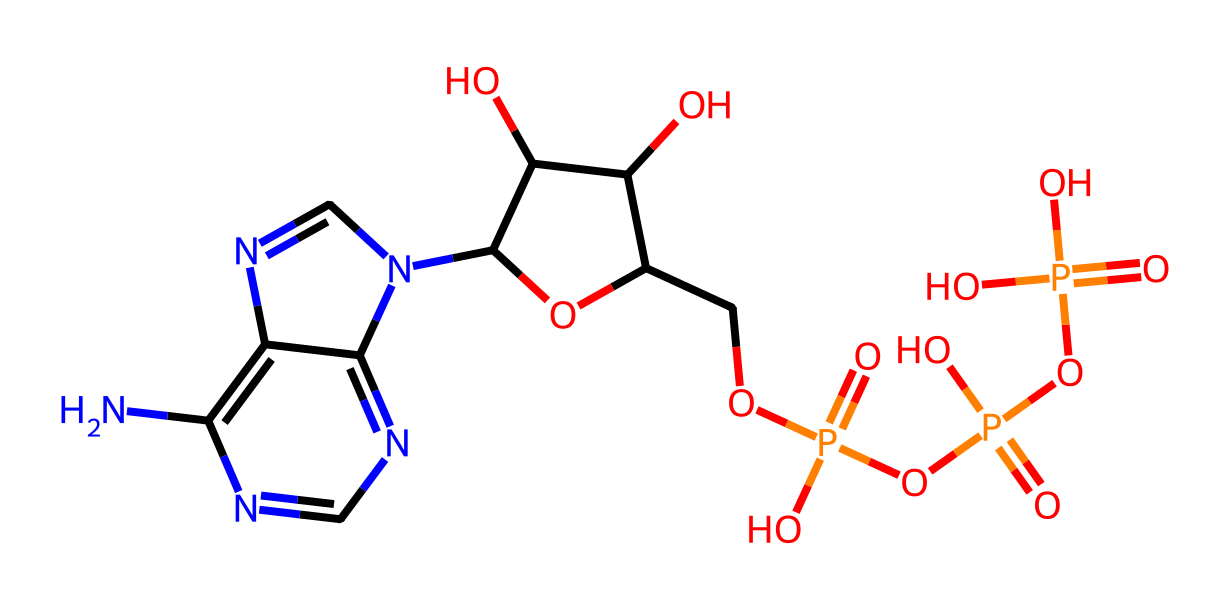What is the main role of ATP in muscles during intense activity? ATP provides energy for muscle contractions, as it is the primary energy carrier in living cells.
Answer: energy carrier How many phosphate groups are present in ATP? ATP contains three phosphate groups attached to its structure, which are crucial for its energetic functions.
Answer: three Which part of the structure indicates that it is a nucleotide? The presence of the ribose sugar and the nitrogenous base (adenine) indicate that ATP is a nucleotide.
Answer: ribose sugar and adenine What type of bond links the phosphate groups in ATP? The phosphate groups in ATP are linked by high-energy phosphoanhydride bonds, essential for energy transfer.
Answer: phosphoanhydride bonds What is the empirical formula of ATP? The empirical formula can be derived by counting all the carbon, hydrogen, nitrogen, oxygen, and phosphorus atoms in the structure of ATP.
Answer: C10H14N5O13P3 What type of compound is ATP classified as? ATP is classified as a nucleotide, specifically a phosphorylated nucleotide because it contains multiple phosphate groups.
Answer: nucleotide How does the structure of ATP contribute to its function as an energy molecule? The structure of ATP with multiple high-energy phosphate bonds allows for significant energy release when these bonds are broken during hydrolysis.
Answer: high-energy phosphate bonds 